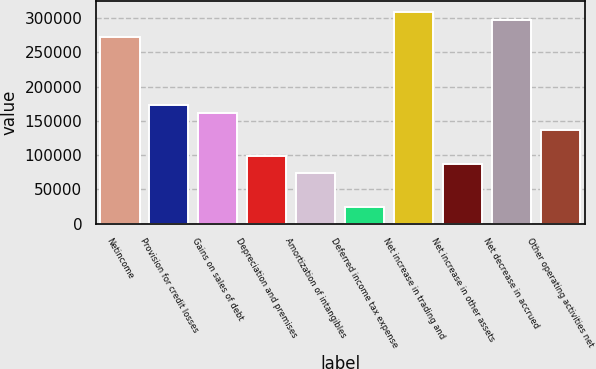<chart> <loc_0><loc_0><loc_500><loc_500><bar_chart><fcel>Netincome<fcel>Provision for credit losses<fcel>Gains on sales of debt<fcel>Depreciation and premises<fcel>Amortization of intangibles<fcel>Deferred income tax expense<fcel>Net increase in trading and<fcel>Net increase in other assets<fcel>Net decrease in accrued<fcel>Other operating activities net<nl><fcel>272290<fcel>173277<fcel>160901<fcel>99017.8<fcel>74264.6<fcel>24758.2<fcel>309420<fcel>86641.2<fcel>297043<fcel>136148<nl></chart> 